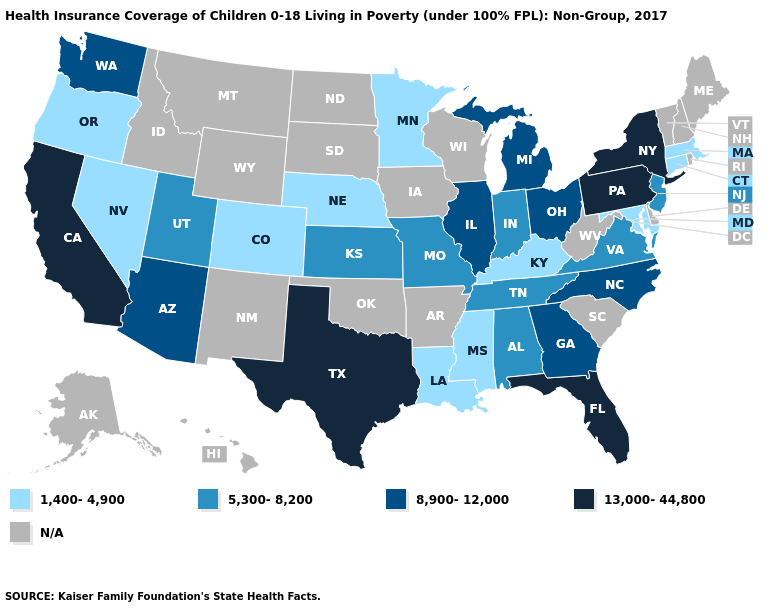What is the value of Massachusetts?
Answer briefly. 1,400-4,900. What is the value of Iowa?
Keep it brief. N/A. Does Colorado have the lowest value in the West?
Short answer required. Yes. What is the value of South Carolina?
Be succinct. N/A. Among the states that border South Dakota , which have the highest value?
Answer briefly. Minnesota, Nebraska. Does the map have missing data?
Short answer required. Yes. How many symbols are there in the legend?
Keep it brief. 5. Does Florida have the highest value in the USA?
Concise answer only. Yes. Among the states that border Idaho , which have the lowest value?
Concise answer only. Nevada, Oregon. Does Illinois have the highest value in the MidWest?
Answer briefly. Yes. Which states hav the highest value in the West?
Answer briefly. California. Name the states that have a value in the range 1,400-4,900?
Concise answer only. Colorado, Connecticut, Kentucky, Louisiana, Maryland, Massachusetts, Minnesota, Mississippi, Nebraska, Nevada, Oregon. Among the states that border New Hampshire , which have the highest value?
Keep it brief. Massachusetts. Does the map have missing data?
Write a very short answer. Yes. Name the states that have a value in the range 13,000-44,800?
Give a very brief answer. California, Florida, New York, Pennsylvania, Texas. 